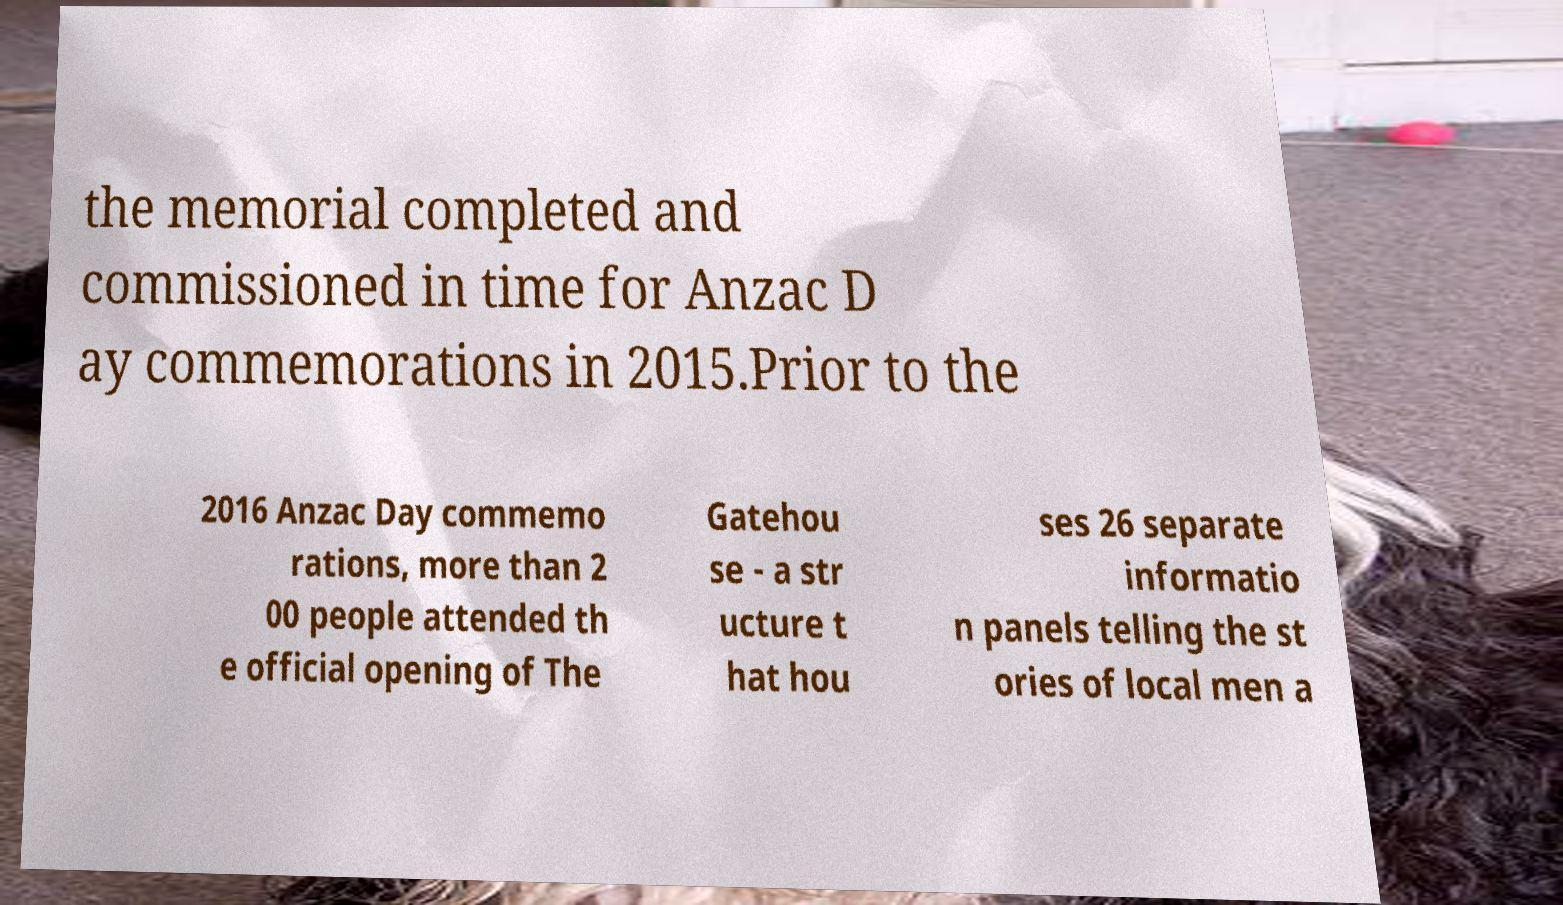Can you accurately transcribe the text from the provided image for me? the memorial completed and commissioned in time for Anzac D ay commemorations in 2015.Prior to the 2016 Anzac Day commemo rations, more than 2 00 people attended th e official opening of The Gatehou se - a str ucture t hat hou ses 26 separate informatio n panels telling the st ories of local men a 